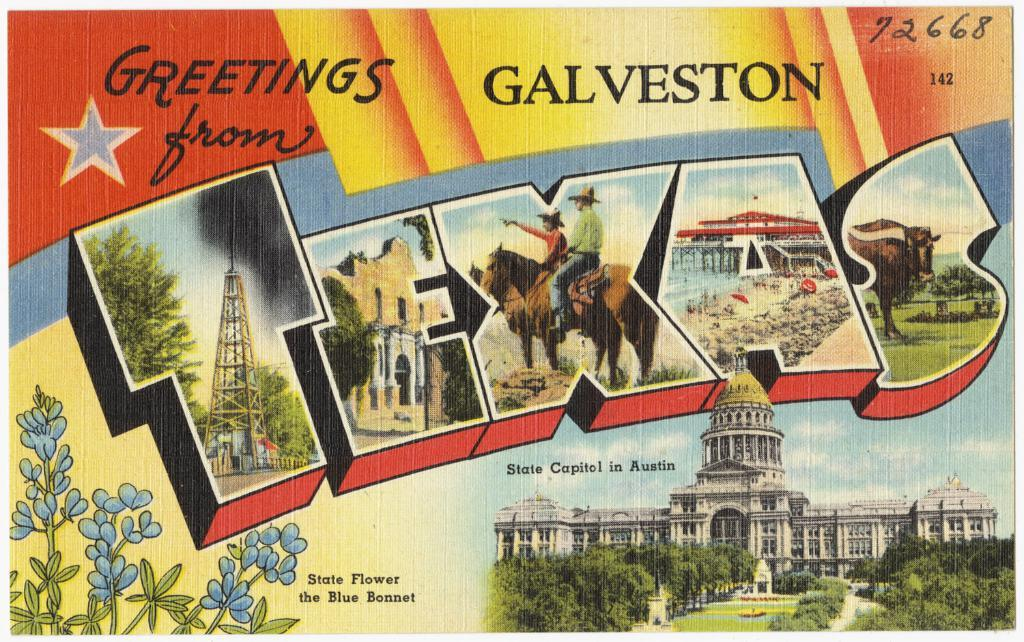<image>
Provide a brief description of the given image. A colorful greeting card that says greetings from Galveston Texas. 